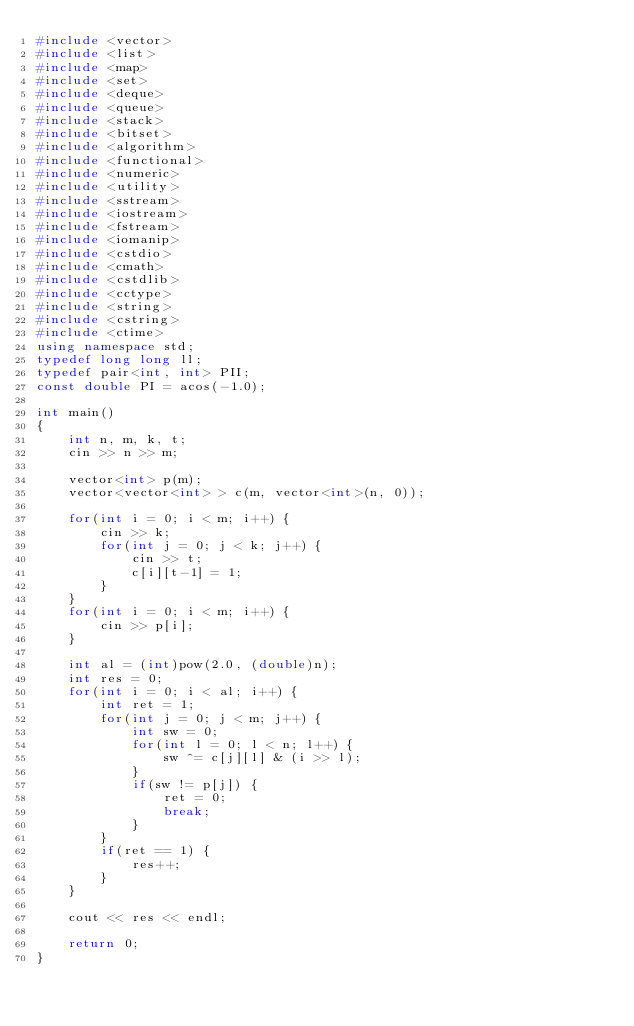Convert code to text. <code><loc_0><loc_0><loc_500><loc_500><_C++_>#include <vector>
#include <list>
#include <map>
#include <set>
#include <deque>
#include <queue>
#include <stack>
#include <bitset>
#include <algorithm>
#include <functional>
#include <numeric>
#include <utility>
#include <sstream>
#include <iostream>
#include <fstream>
#include <iomanip>
#include <cstdio>
#include <cmath>
#include <cstdlib>
#include <cctype>
#include <string>
#include <cstring>
#include <ctime>
using namespace std;
typedef long long ll;
typedef pair<int, int> PII;
const double PI = acos(-1.0);

int main()
{
	int n, m, k, t;
	cin >> n >> m;

	vector<int> p(m);
	vector<vector<int> > c(m, vector<int>(n, 0));

	for(int i = 0; i < m; i++) {
		cin >> k;
		for(int j = 0; j < k; j++) {
			cin >> t;
			c[i][t-1] = 1;
		}
	}
	for(int i = 0; i < m; i++) {
		cin >> p[i];
	}

	int al = (int)pow(2.0, (double)n);
	int res = 0;
	for(int i = 0; i < al; i++) {
		int ret = 1;
		for(int j = 0; j < m; j++) {
			int sw = 0;
			for(int l = 0; l < n; l++) {
				sw ^= c[j][l] & (i >> l);
			}
			if(sw != p[j]) {
				ret = 0;
				break;
			}
		}
		if(ret == 1) {
			res++;
		}
	}

	cout << res << endl;

    return 0;
}
</code> 